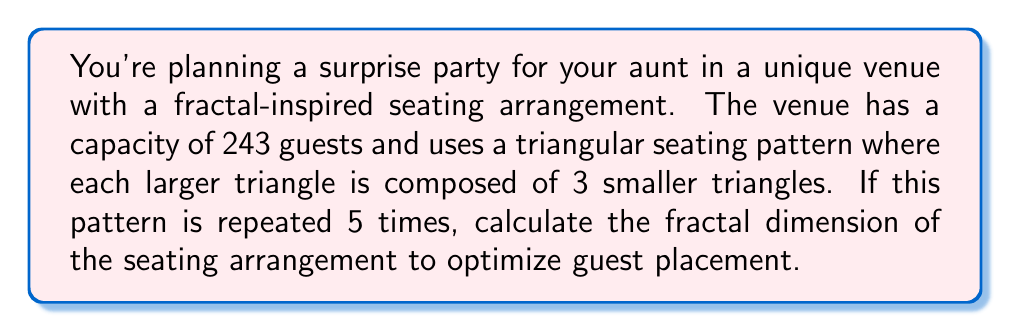Help me with this question. To calculate the fractal dimension of the seating arrangement, we'll use the box-counting method. In this case, we have a self-similar fractal pattern.

Step 1: Identify the scaling factor (r)
Each iteration reduces the size of the triangles by a factor of 1/2.
$r = \frac{1}{2}$

Step 2: Determine the number of self-similar pieces (N)
Each triangle is divided into 3 smaller triangles.
$N = 3$

Step 3: Use the fractal dimension formula
The fractal dimension D is given by:
$$D = \frac{\log N}{\log(\frac{1}{r})}$$

Step 4: Substitute the values
$$D = \frac{\log 3}{\log(\frac{1}{1/2})} = \frac{\log 3}{\log 2}$$

Step 5: Calculate the result
$$D = \frac{\log 3}{\log 2} \approx 1.5850$$

This fractal dimension indicates that the seating arrangement fills more space than a one-dimensional line (D=1) but less than a two-dimensional plane (D=2), which is characteristic of fractal patterns.
Answer: $D = \frac{\log 3}{\log 2} \approx 1.5850$ 